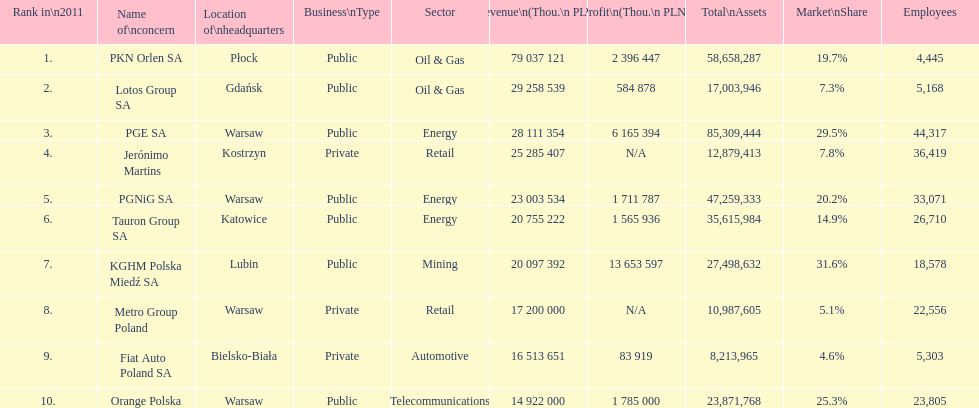Give me the full table as a dictionary. {'header': ['Rank in\\n2011', 'Name of\\nconcern', 'Location of\\nheadquarters', 'Business\\nType', 'Sector', 'Revenue\\n(Thou.\\n\xa0PLN)', 'Profit\\n(Thou.\\n\xa0PLN)', 'Total\\nAssets', 'Market\\nShare', 'Employees'], 'rows': [['1.', 'PKN Orlen SA', 'Płock', 'Public', 'Oil & Gas', '79 037 121', '2 396 447', '58,658,287', '19.7%', '4,445'], ['2.', 'Lotos Group SA', 'Gdańsk', 'Public', 'Oil & Gas', '29 258 539', '584 878', '17,003,946', '7.3%', '5,168'], ['3.', 'PGE SA', 'Warsaw', 'Public', 'Energy', '28 111 354', '6 165 394', '85,309,444', '29.5%', '44,317'], ['4.', 'Jerónimo Martins', 'Kostrzyn', 'Private', 'Retail', '25 285 407', 'N/A', '12,879,413', '7.8%', '36,419'], ['5.', 'PGNiG SA', 'Warsaw', 'Public', 'Energy', '23 003 534', '1 711 787', '47,259,333', '20.2%', '33,071'], ['6.', 'Tauron Group SA', 'Katowice', 'Public', 'Energy', '20 755 222', '1 565 936', '35,615,984', '14.9%', '26,710'], ['7.', 'KGHM Polska Miedź SA', 'Lubin', 'Public', 'Mining', '20 097 392', '13 653 597', '27,498,632', '31.6%', '18,578'], ['8.', 'Metro Group Poland', 'Warsaw', 'Private', 'Retail', '17 200 000', 'N/A', '10,987,605', '5.1%', '22,556'], ['9.', 'Fiat Auto Poland SA', 'Bielsko-Biała', 'Private', 'Automotive', '16 513 651', '83 919', '8,213,965', '4.6%', '5,303'], ['10.', 'Orange Polska', 'Warsaw', 'Public', 'Telecommunications', '14 922 000', '1 785 000', '23,871,768', '25.3%', '23,805']]} What company has the top number of employees? PGE SA. 